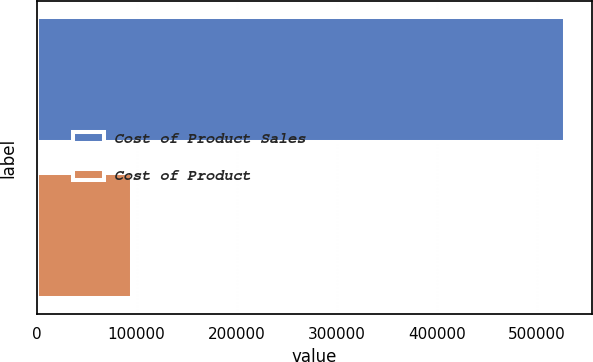Convert chart to OTSL. <chart><loc_0><loc_0><loc_500><loc_500><bar_chart><fcel>Cost of Product Sales<fcel>Cost of Product<nl><fcel>528528<fcel>95310<nl></chart> 